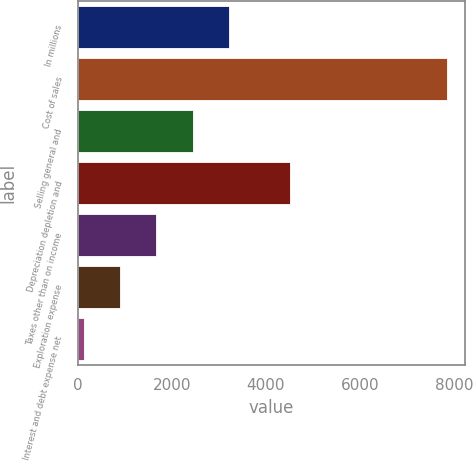<chart> <loc_0><loc_0><loc_500><loc_500><bar_chart><fcel>In millions<fcel>Cost of sales<fcel>Selling general and<fcel>Depreciation depletion and<fcel>Taxes other than on income<fcel>Exploration expense<fcel>Interest and debt expense net<nl><fcel>3215.6<fcel>7844<fcel>2444.2<fcel>4511<fcel>1672.8<fcel>901.4<fcel>130<nl></chart> 